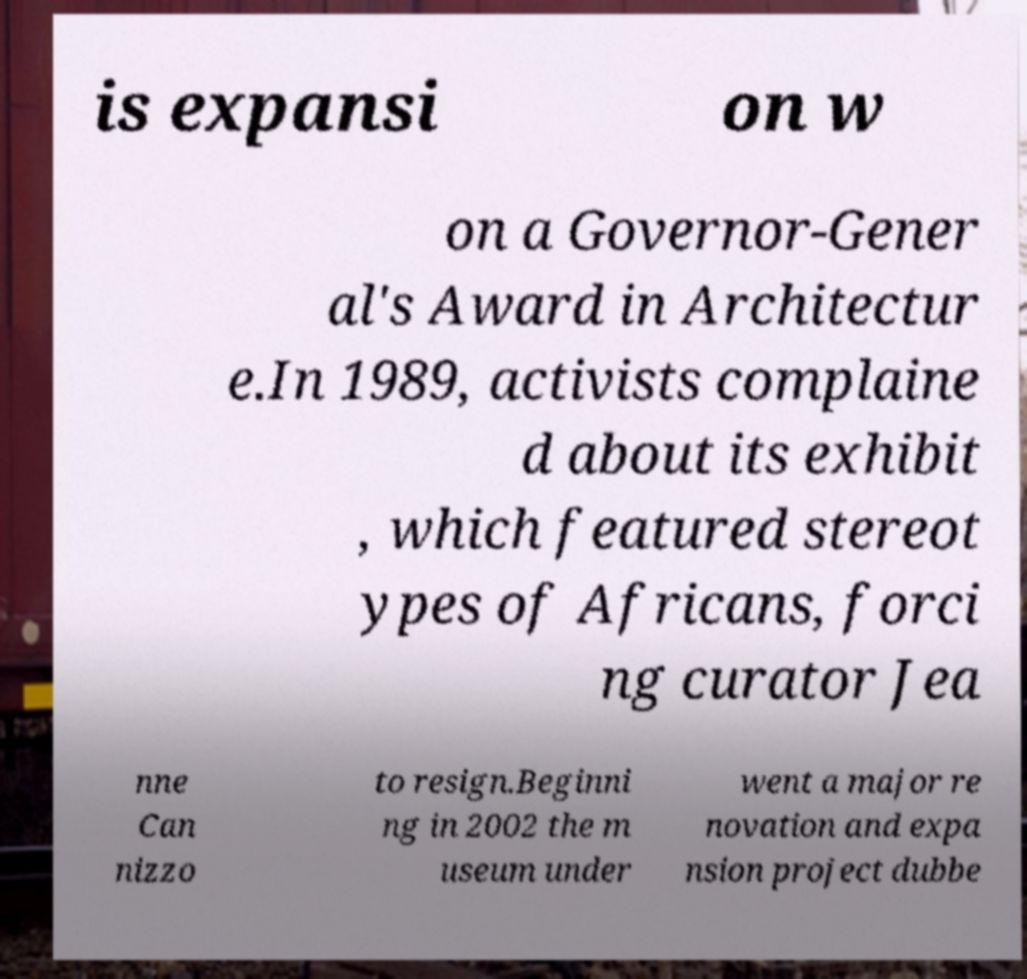Please read and relay the text visible in this image. What does it say? is expansi on w on a Governor-Gener al's Award in Architectur e.In 1989, activists complaine d about its exhibit , which featured stereot ypes of Africans, forci ng curator Jea nne Can nizzo to resign.Beginni ng in 2002 the m useum under went a major re novation and expa nsion project dubbe 